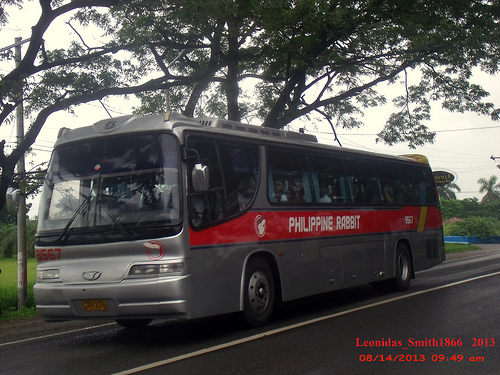<image>
Can you confirm if the bus is in the road? No. The bus is not contained within the road. These objects have a different spatial relationship. 